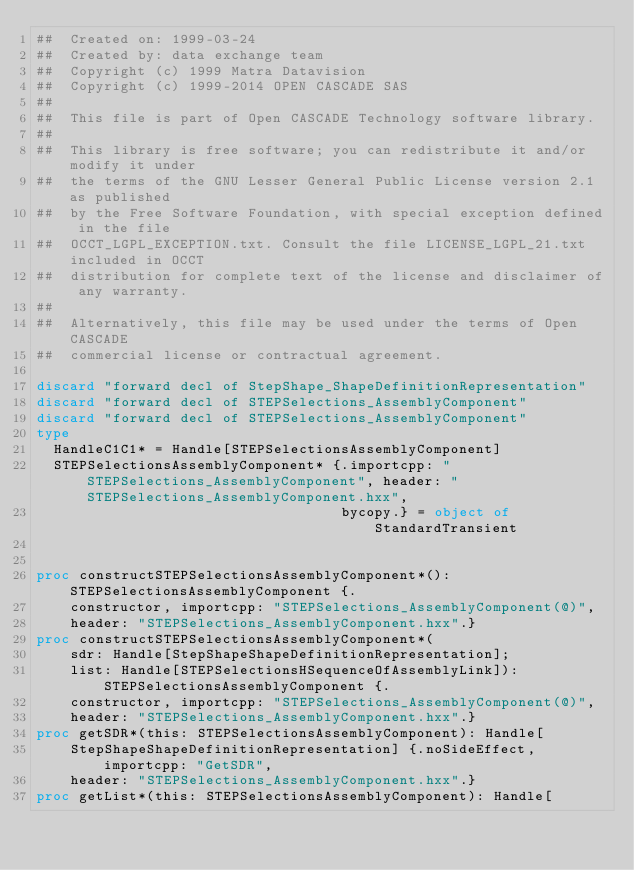Convert code to text. <code><loc_0><loc_0><loc_500><loc_500><_Nim_>##  Created on: 1999-03-24
##  Created by: data exchange team
##  Copyright (c) 1999 Matra Datavision
##  Copyright (c) 1999-2014 OPEN CASCADE SAS
##
##  This file is part of Open CASCADE Technology software library.
##
##  This library is free software; you can redistribute it and/or modify it under
##  the terms of the GNU Lesser General Public License version 2.1 as published
##  by the Free Software Foundation, with special exception defined in the file
##  OCCT_LGPL_EXCEPTION.txt. Consult the file LICENSE_LGPL_21.txt included in OCCT
##  distribution for complete text of the license and disclaimer of any warranty.
##
##  Alternatively, this file may be used under the terms of Open CASCADE
##  commercial license or contractual agreement.

discard "forward decl of StepShape_ShapeDefinitionRepresentation"
discard "forward decl of STEPSelections_AssemblyComponent"
discard "forward decl of STEPSelections_AssemblyComponent"
type
  HandleC1C1* = Handle[STEPSelectionsAssemblyComponent]
  STEPSelectionsAssemblyComponent* {.importcpp: "STEPSelections_AssemblyComponent", header: "STEPSelections_AssemblyComponent.hxx",
                                    bycopy.} = object of StandardTransient


proc constructSTEPSelectionsAssemblyComponent*(): STEPSelectionsAssemblyComponent {.
    constructor, importcpp: "STEPSelections_AssemblyComponent(@)",
    header: "STEPSelections_AssemblyComponent.hxx".}
proc constructSTEPSelectionsAssemblyComponent*(
    sdr: Handle[StepShapeShapeDefinitionRepresentation];
    list: Handle[STEPSelectionsHSequenceOfAssemblyLink]): STEPSelectionsAssemblyComponent {.
    constructor, importcpp: "STEPSelections_AssemblyComponent(@)",
    header: "STEPSelections_AssemblyComponent.hxx".}
proc getSDR*(this: STEPSelectionsAssemblyComponent): Handle[
    StepShapeShapeDefinitionRepresentation] {.noSideEffect, importcpp: "GetSDR",
    header: "STEPSelections_AssemblyComponent.hxx".}
proc getList*(this: STEPSelectionsAssemblyComponent): Handle[</code> 